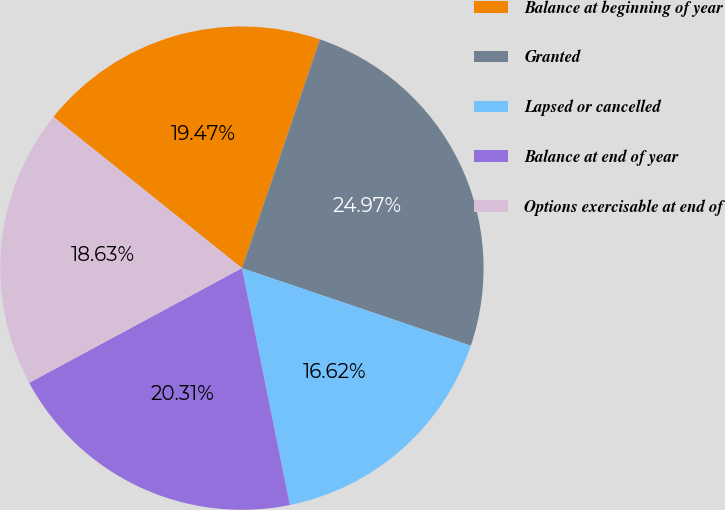Convert chart. <chart><loc_0><loc_0><loc_500><loc_500><pie_chart><fcel>Balance at beginning of year<fcel>Granted<fcel>Lapsed or cancelled<fcel>Balance at end of year<fcel>Options exercisable at end of<nl><fcel>19.47%<fcel>24.97%<fcel>16.62%<fcel>20.31%<fcel>18.63%<nl></chart> 